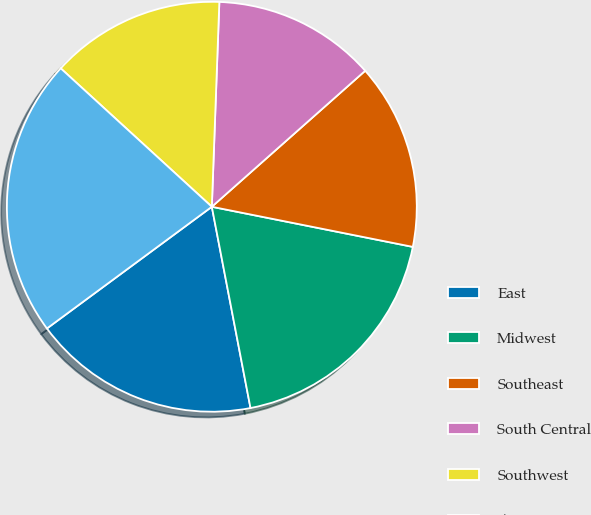Convert chart to OTSL. <chart><loc_0><loc_0><loc_500><loc_500><pie_chart><fcel>East<fcel>Midwest<fcel>Southeast<fcel>South Central<fcel>Southwest<fcel>West<nl><fcel>17.9%<fcel>18.84%<fcel>14.68%<fcel>12.87%<fcel>13.78%<fcel>21.92%<nl></chart> 